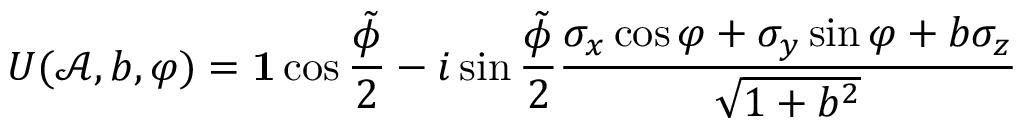<formula> <loc_0><loc_0><loc_500><loc_500>U ( \mathcal { A } , b , \varphi ) = 1 \cos \frac { \tilde { \phi } } { 2 } - i \sin \frac { \tilde { \phi } } { 2 } \frac { \sigma _ { x } \cos \varphi + \sigma _ { y } \sin \varphi + b \sigma _ { z } } { \sqrt { 1 + b ^ { 2 } } }</formula> 